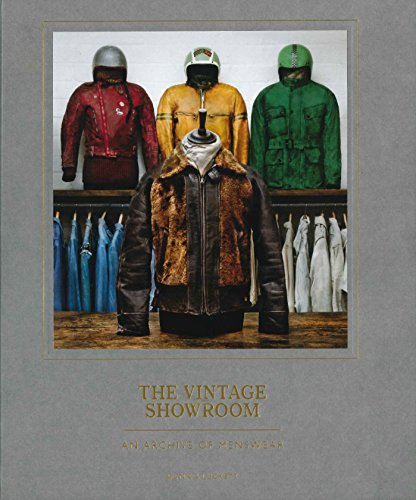What eras do the jackets on the cover represent? The jackets on the cover likely represent fashion from mid-20th century, particularly from the 1940s to the 1970s. These eras saw varied fashion shifts, from the rugged motifs of post-war years to the bold, expressive styles of the late 60s and 70s. 